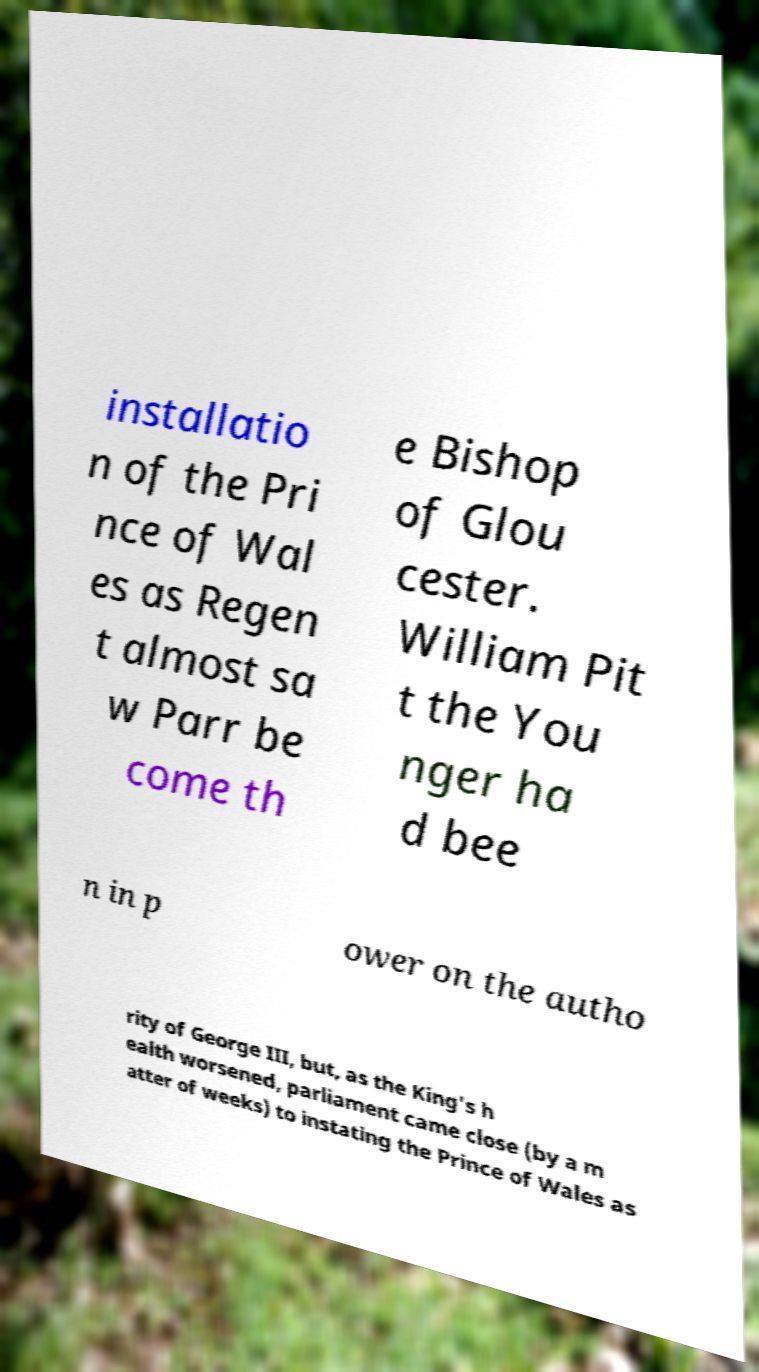What messages or text are displayed in this image? I need them in a readable, typed format. installatio n of the Pri nce of Wal es as Regen t almost sa w Parr be come th e Bishop of Glou cester. William Pit t the You nger ha d bee n in p ower on the autho rity of George III, but, as the King's h ealth worsened, parliament came close (by a m atter of weeks) to instating the Prince of Wales as 